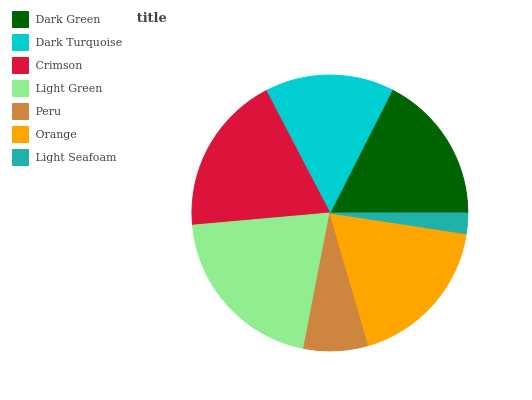Is Light Seafoam the minimum?
Answer yes or no. Yes. Is Light Green the maximum?
Answer yes or no. Yes. Is Dark Turquoise the minimum?
Answer yes or no. No. Is Dark Turquoise the maximum?
Answer yes or no. No. Is Dark Green greater than Dark Turquoise?
Answer yes or no. Yes. Is Dark Turquoise less than Dark Green?
Answer yes or no. Yes. Is Dark Turquoise greater than Dark Green?
Answer yes or no. No. Is Dark Green less than Dark Turquoise?
Answer yes or no. No. Is Dark Green the high median?
Answer yes or no. Yes. Is Dark Green the low median?
Answer yes or no. Yes. Is Crimson the high median?
Answer yes or no. No. Is Light Green the low median?
Answer yes or no. No. 